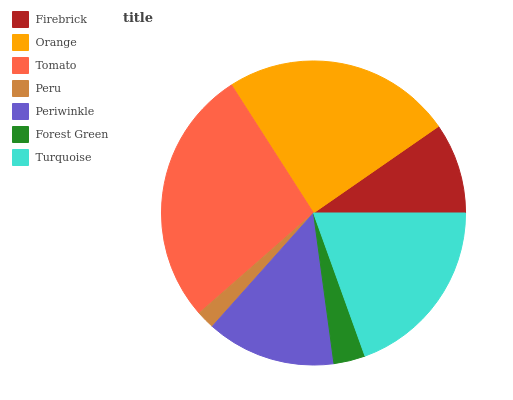Is Peru the minimum?
Answer yes or no. Yes. Is Tomato the maximum?
Answer yes or no. Yes. Is Orange the minimum?
Answer yes or no. No. Is Orange the maximum?
Answer yes or no. No. Is Orange greater than Firebrick?
Answer yes or no. Yes. Is Firebrick less than Orange?
Answer yes or no. Yes. Is Firebrick greater than Orange?
Answer yes or no. No. Is Orange less than Firebrick?
Answer yes or no. No. Is Periwinkle the high median?
Answer yes or no. Yes. Is Periwinkle the low median?
Answer yes or no. Yes. Is Firebrick the high median?
Answer yes or no. No. Is Turquoise the low median?
Answer yes or no. No. 